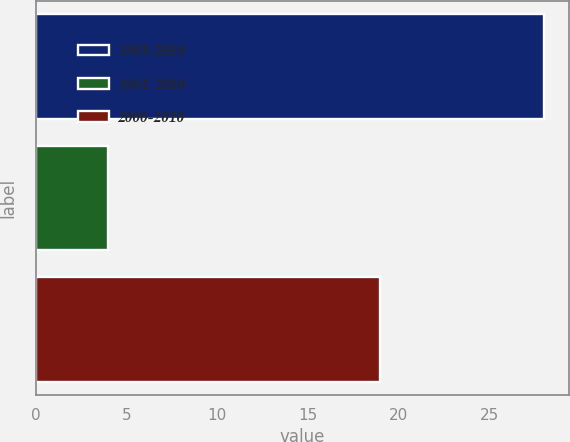Convert chart to OTSL. <chart><loc_0><loc_0><loc_500><loc_500><bar_chart><fcel>1985-2010<fcel>1984-2010<fcel>2000-2010<nl><fcel>28<fcel>4<fcel>19<nl></chart> 